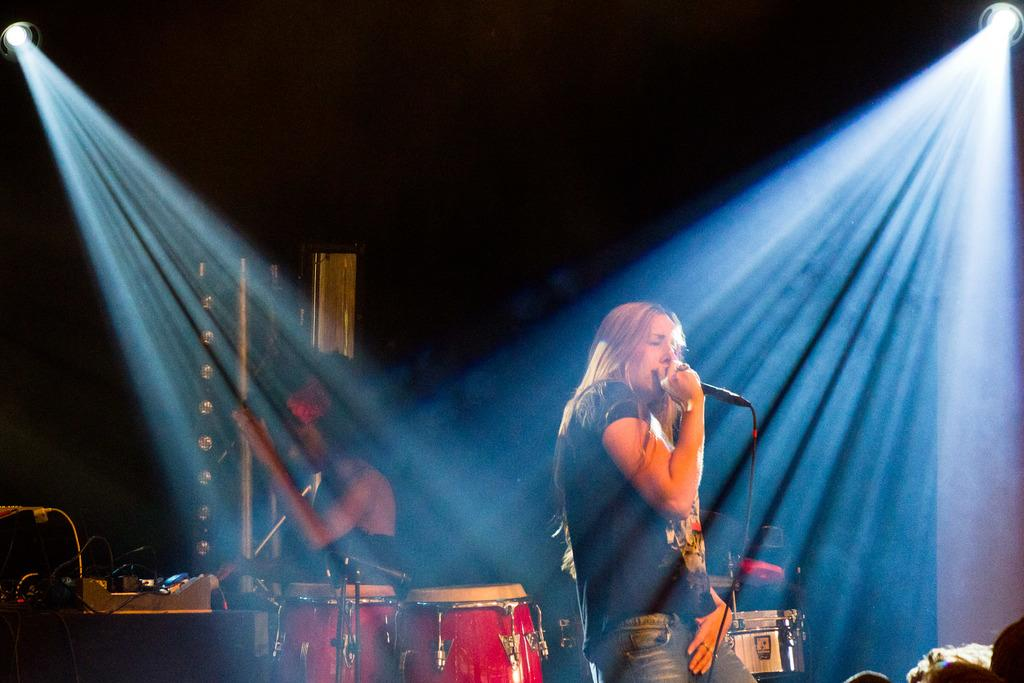How many women are in the image? There are two women in the image. What are the women doing in the image? One woman is singing on a microphone, and the other woman is playing drums. What can be seen in the background of the image? There is a wall, a door, and a light in the background of the image. What type of copper material is used to make the bikes in the image? There are no bikes present in the image, and therefore no copper material can be observed. 